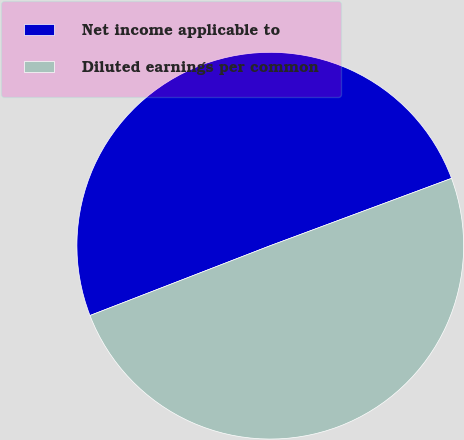<chart> <loc_0><loc_0><loc_500><loc_500><pie_chart><fcel>Net income applicable to<fcel>Diluted earnings per common<nl><fcel>50.22%<fcel>49.78%<nl></chart> 